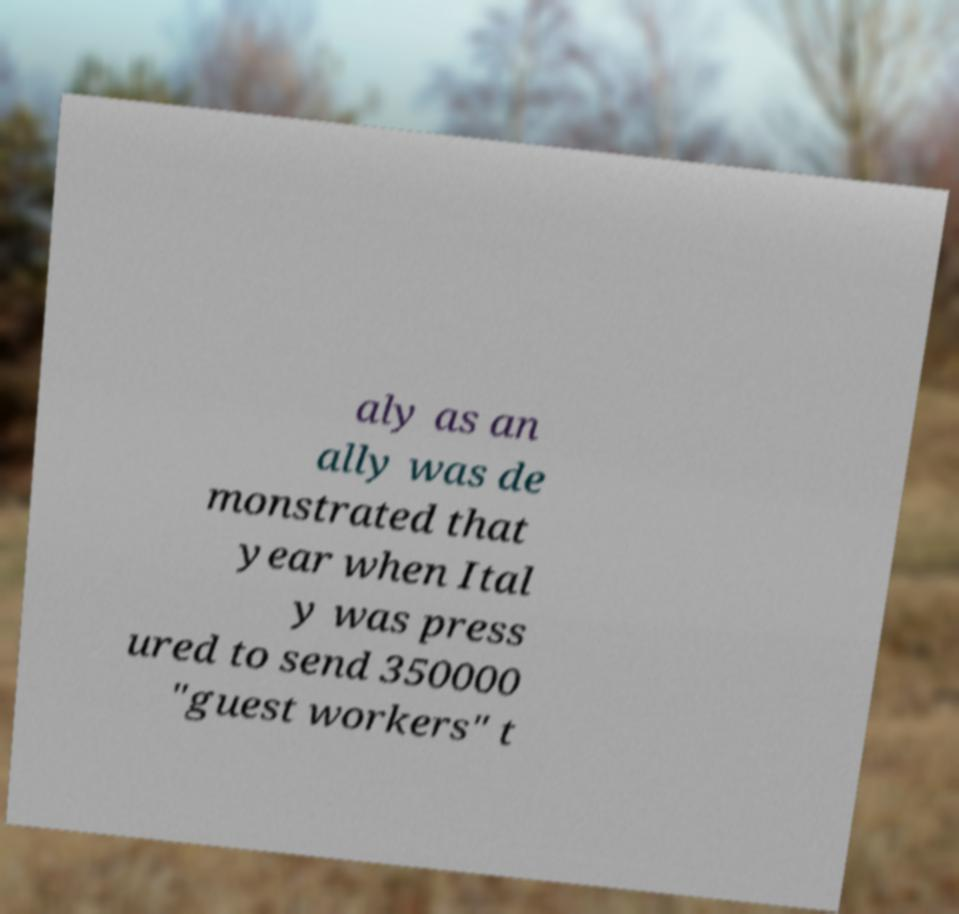Please identify and transcribe the text found in this image. aly as an ally was de monstrated that year when Ital y was press ured to send 350000 "guest workers" t 